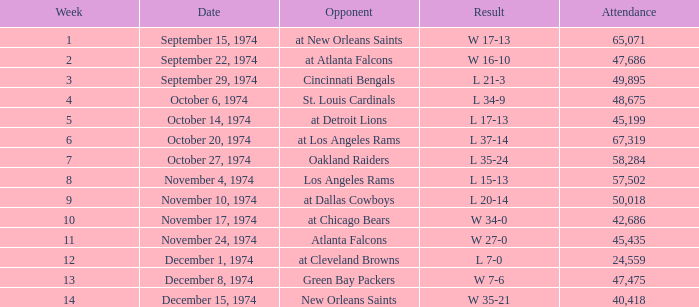What was the attendance when they played at Detroit Lions? 45199.0. 